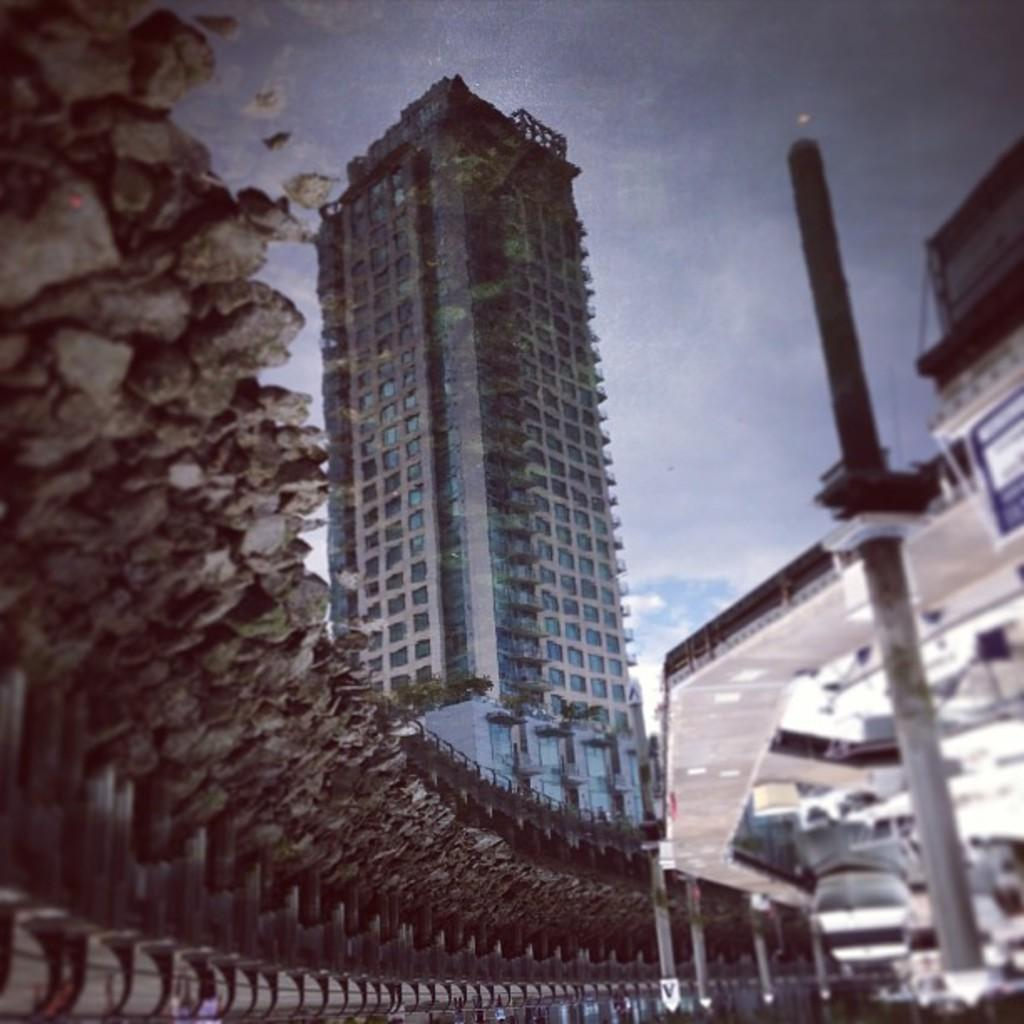What type of natural elements can be seen in the image? There are stones, trees, and a bridge visible in the image. What man-made structures are present in the image? There are buildings and poles visible in the image. What is the primary mode of transportation in the image? A vehicle is visible in the image. What is the background of the image? The sky is visible in the background of the image. How many unspecified objects are present in the image? There are some unspecified objects in the image. What type of linen is draped over the front of the frame in the image? There is no linen or frame present in the image. How does the vehicle walk across the bridge in the image? The vehicle does not walk across the bridge; it is a mode of transportation that moves on wheels. 